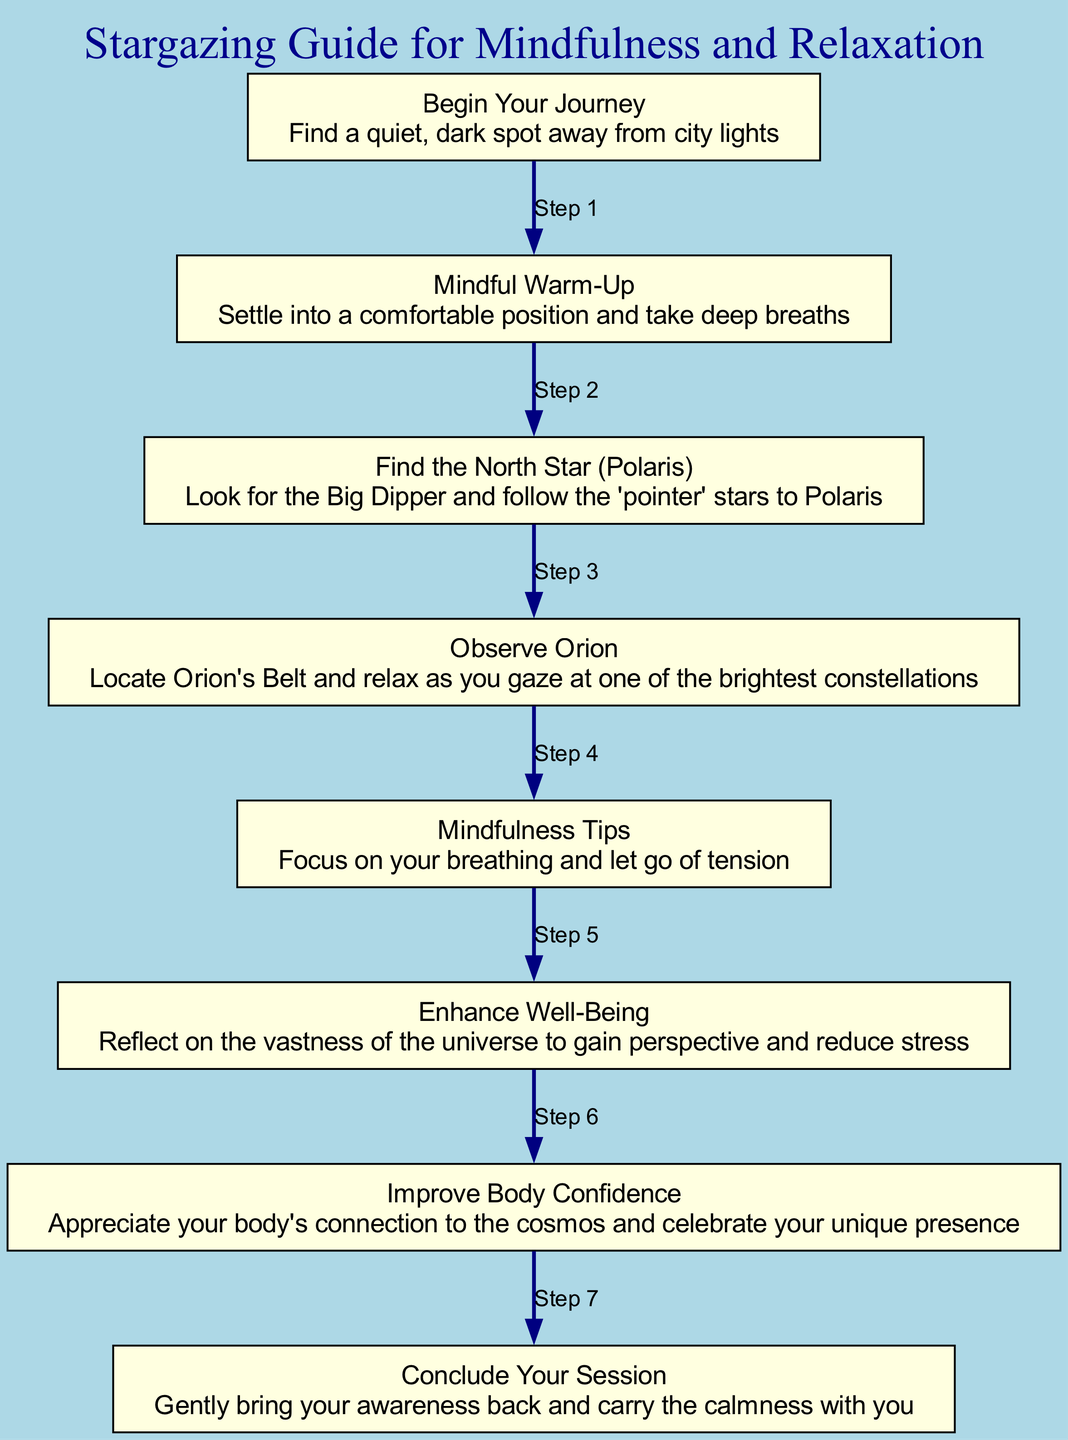What is the first step in the stargazing guide? The first step in the diagram is labeled "Begin Your Journey", which instructs to find a quiet, dark spot away from city lights. This is the starting node connected to the warm-up step.
Answer: Begin Your Journey How many nodes are present in the diagram? By counting each unique node presented in the diagram, we find there are eight nodes listed: start, warmup, north_star, orion, mindfulness_tips, wellbeing, body_confidence, and end.
Answer: Eight What does the arrow from "wellbeing" point to? Following the flow of the diagram, the arrow leads from "wellbeing" to "body_confidence", indicating the next activity after enhancing well-being.
Answer: body_confidence What are the last two nodes in the sequence? The last two nodes in the flowchart, as indicated by their positions and connections, are "body_confidence" followed by "end". These are the concluding steps of the mindfulness stargazing activity.
Answer: body_confidence, end How does observing Orion relate to mindfulness? Observing Orion is emphasized as a significant activity within the guide that allows the participant to relax and enjoy one of the brightest constellations, which enhances the mindfulness and relaxation journey.
Answer: Observe Orion What activity follows the "Mindful Warm-Up"? In the flow of the diagram, after the "Mindful Warm-Up", the next activity is to "Find the North Star (Polaris)", which is the subsequent step in the stargazing guide.
Answer: Find the North Star (Polaris) Which step emphasizes the connection with the cosmos? The node labeled "Improve Body Confidence" directly discusses appreciating one's body and its connection to the cosmos, making it the key link connecting self-image to the celestial view.
Answer: Improve Body Confidence What should one focus on during the "Mindfulness Tips" step? The description under the "Mindfulness Tips" node advises focusing on breathing and releasing tension, which is crucial for enhancing mindfulness during stargazing.
Answer: Your breathing and tension 